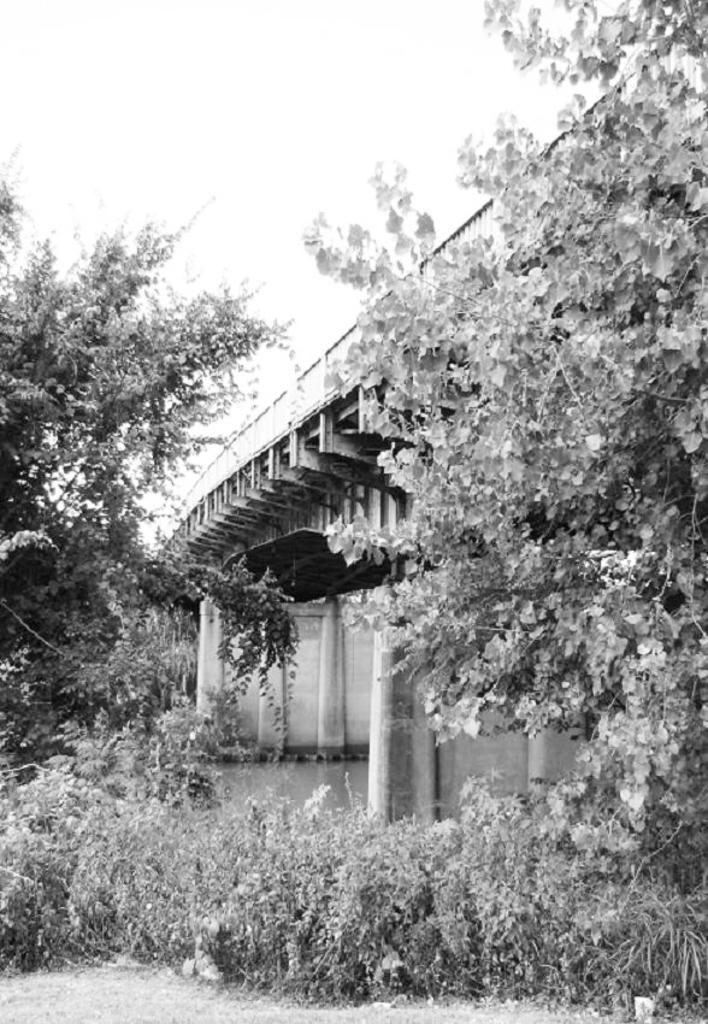What is the color scheme of the image? The image is black and white. What type of structure can be seen in the image? There is a bridge in the image. What type of vegetation is present in the image? Trees and plants are visible in the image. What part of the natural environment is visible in the image? The sky and water are visible in the image. What is the weight of the level in the image? There is no level present in the image, so it is not possible to determine its weight. 